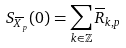<formula> <loc_0><loc_0><loc_500><loc_500>S _ { \overline { X } _ { p } } ( 0 ) = \sum _ { k \in \mathbb { Z } } \overline { R } _ { k , p }</formula> 